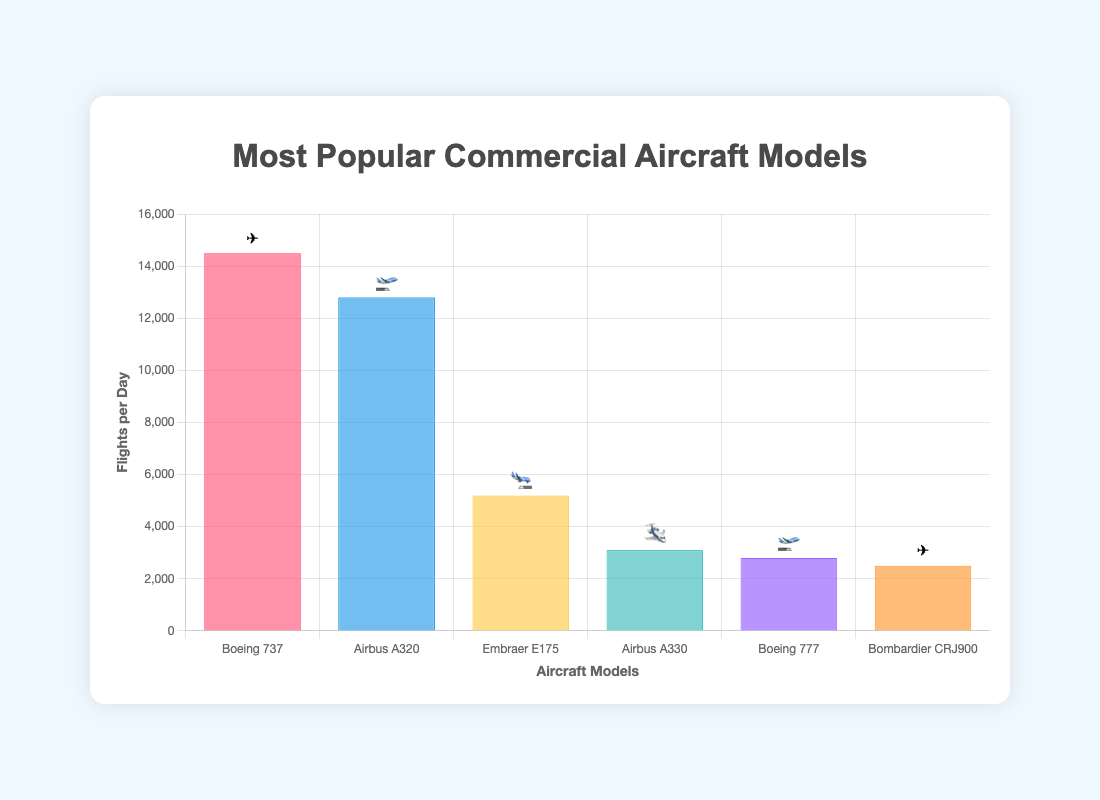What's the most popular commercial aircraft model by number of flights per day? The bar chart shows the number of flights per day for each aircraft model. The highest bar represents the most popular model.
Answer: Boeing 737 How many flights per day does the Embraer E175 have? Check the height of the bar representing the Embraer E175 and refer to the y-axis.
Answer: 5200 What is the difference in the number of flights per day between the Boeing 737 and the Airbus A320? Find the number of flights per day for both models (14500 for Boeing 737 and 12800 for Airbus A320), then subtract the smaller number from the larger number.
Answer: 1700 Which aircraft model with the highest number of flights per day also has an emoji? Identify the model with the highest flights per day and check its associated emoji in the chart.
Answer: Boeing 737 ✈️ How many more flights per day does the Airbus A320 have compared to the Boeing 777? Find the number of flights per day for both models (12800 for Airbus A320 and 2800 for Boeing 777), then subtract the smaller number from the larger number.
Answer: 10000 What is the total number of flights per day for all models? Add up the number of flights per day for each model: 14500 + 12800 + 5200 + 3100 + 2800 + 2500.
Answer: 40900 Which two aircraft models have the same emoji representation in the chart? Review the chart to find models with similar emojis.
Answer: Boeing 737 and Bombardier CRJ900 ✈️ Which aircraft model has the fewest flights per day and what emoji represents it? Check the bar with the lowest height, representing the fewest flights per day, and note the associated emoji.
Answer: Bombardier CRJ900 ✈️ How does the number of flights per day of the Airbus A330 compare to the Airbus A320? Identify the number of flights per day for each model (3100 for Airbus A330 and 12800 for Airbus A320) and compare them to see which is greater.
Answer: Airbux A320 has more flights 